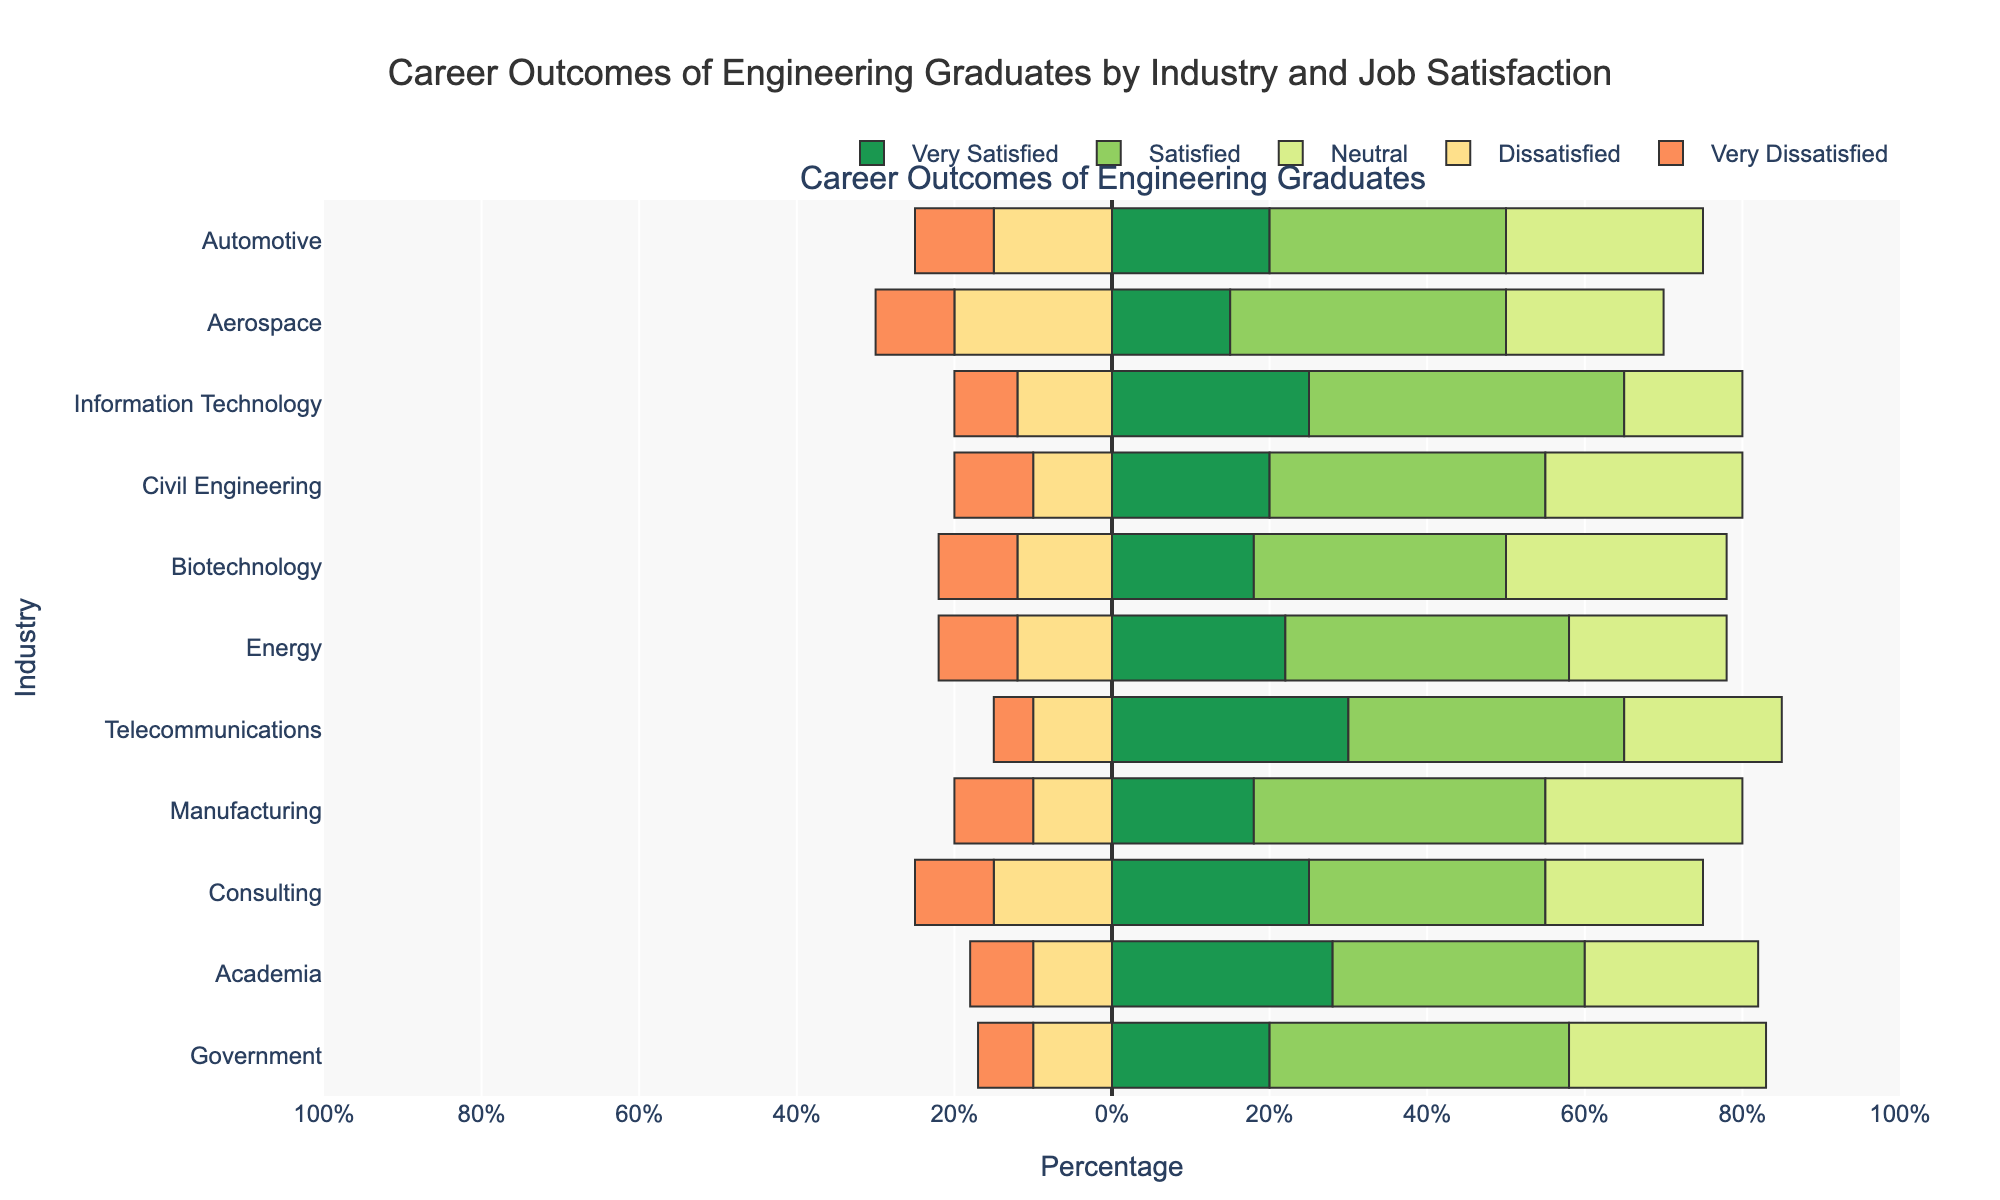What industry has the highest percentage of graduates who are 'Very Satisfied'? The 'Very Satisfied' category is represented by the first set of bars in the figure. Looking at the bars, Telecommunications has the longest bar, indicating the highest percentage.
Answer: Telecommunications Which industry has the lowest percentage of graduates who are 'Neutral'? The 'Neutral' category is represented by the third set of bars in the figure. Comparing the lengths of the bars, Information Technology has the shortest bar in this category.
Answer: Information Technology What is the combined percentage of 'Satisfied' and 'Very Satisfied' graduates in the Energy industry? To get the combined percentage, add the values for 'Satisfied' (36%) and 'Very Satisfied' (22%) for the Energy industry. That is 36 + 22.
Answer: 58% How does the percentage of 'Dissatisfied' graduates in Aerospace compare to that in Civil Engineering? The 'Dissatisfied' category is represented by the fourth set of bars. The Aerospace industry has a 20% 'Dissatisfied' rate, while Civil Engineering has 10%. Therefore, Aerospace has a higher percentage.
Answer: Aerospace has a higher percentage Which industry has a higher percentage of 'Very Dissatisfied' graduates: Manufacturing or Consulting? The 'Very Dissatisfied' category is represented by the fifth set of bars. Both Manufacturing and Consulting have equal lengths of bars in this category, indicating they have the same percentage.
Answer: Equal percentage What is the percentage difference between 'Satisfied' graduates in the Automotive and Government industries? For Automotive, the 'Satisfied' percentage is 30%. For Government, it is 38%. The difference is 38 - 30.
Answer: 8% Which industry appears to have the most evenly distributed job satisfaction levels? By observing which set of bars have the least variation in bar lengths among all categories, Civil Engineering stands out as having relatively even distribution across all satisfaction levels.
Answer: Civil Engineering Among the industries listed, which has the highest percentage of graduates who are either 'Neutral' or 'Dissatisfied'? Sum the percentages of 'Neutral' and 'Dissatisfied' for each industry and compare. For example, for Aerospace: 20% (Neutral) + 20% (Dissatisfied) = 40%. Among all, Biotechnology has the highest with 28% (Neutral) + 12% (Dissatisfied) = 40%.
Answer: Biotechnology 